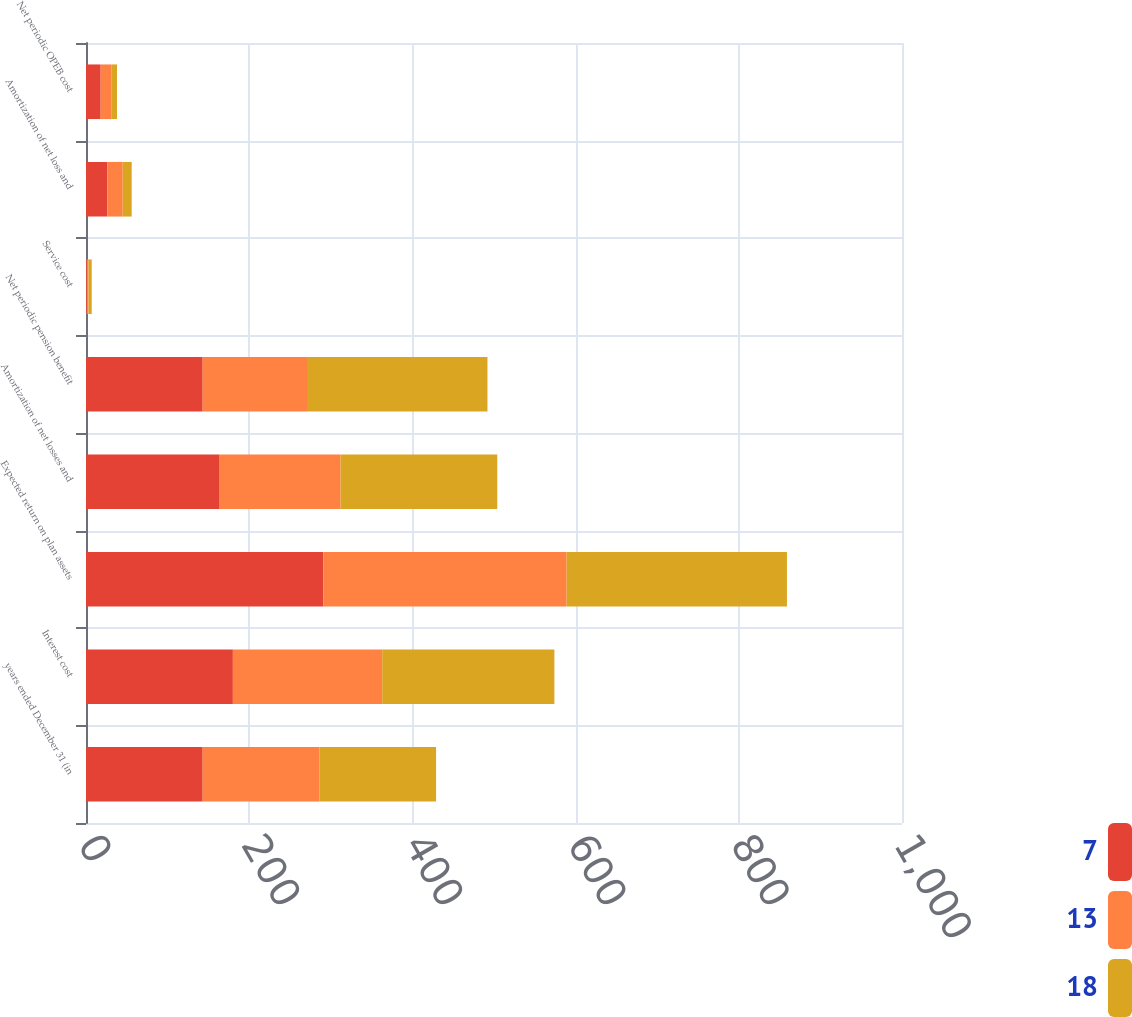<chart> <loc_0><loc_0><loc_500><loc_500><stacked_bar_chart><ecel><fcel>years ended December 31 (in<fcel>Interest cost<fcel>Expected return on plan assets<fcel>Amortization of net losses and<fcel>Net periodic pension benefit<fcel>Service cost<fcel>Amortization of net loss and<fcel>Net periodic OPEB cost<nl><fcel>7<fcel>143<fcel>180<fcel>291<fcel>163<fcel>143<fcel>1<fcel>26<fcel>18<nl><fcel>13<fcel>143<fcel>183<fcel>298<fcel>149<fcel>129<fcel>2<fcel>19<fcel>13<nl><fcel>18<fcel>143<fcel>211<fcel>270<fcel>192<fcel>220<fcel>4<fcel>11<fcel>7<nl></chart> 